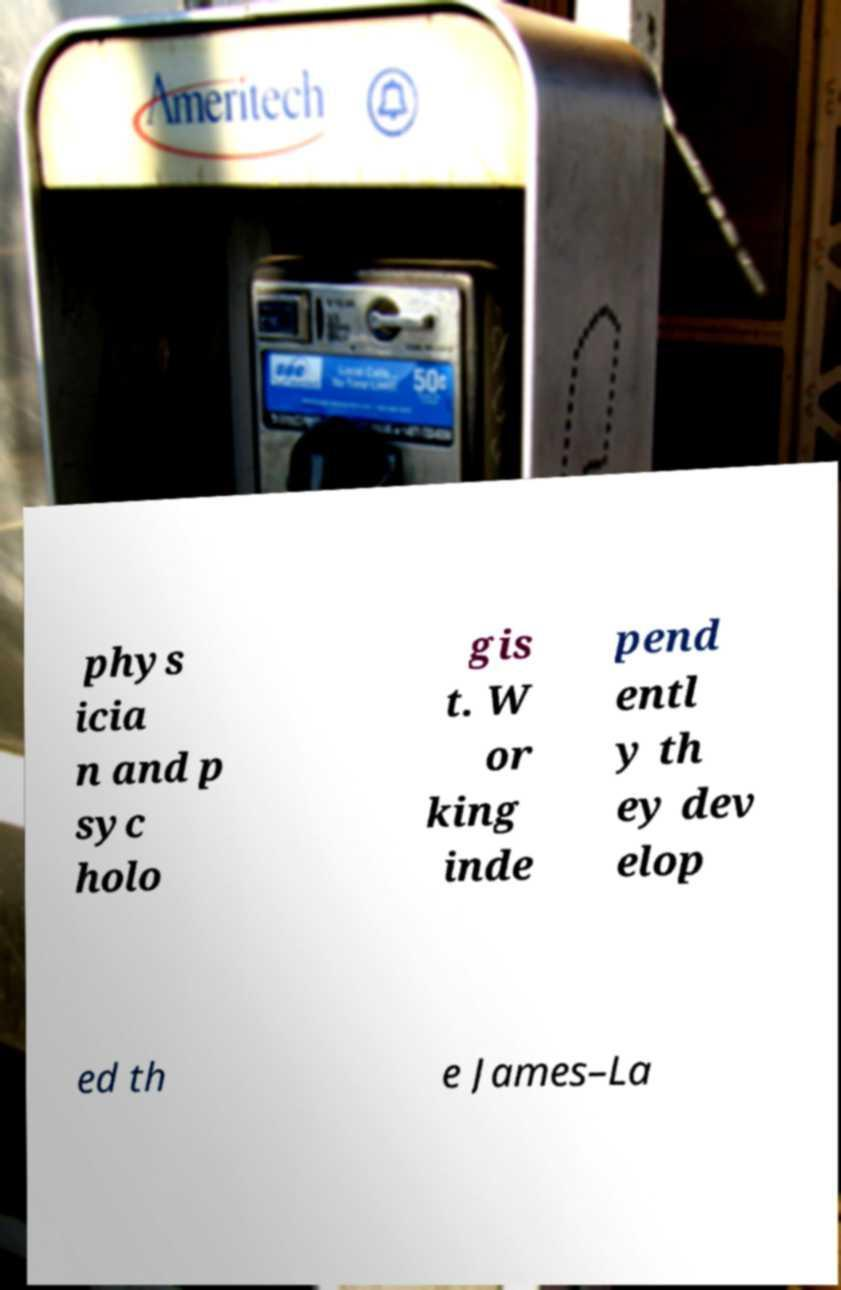Could you assist in decoding the text presented in this image and type it out clearly? phys icia n and p syc holo gis t. W or king inde pend entl y th ey dev elop ed th e James–La 